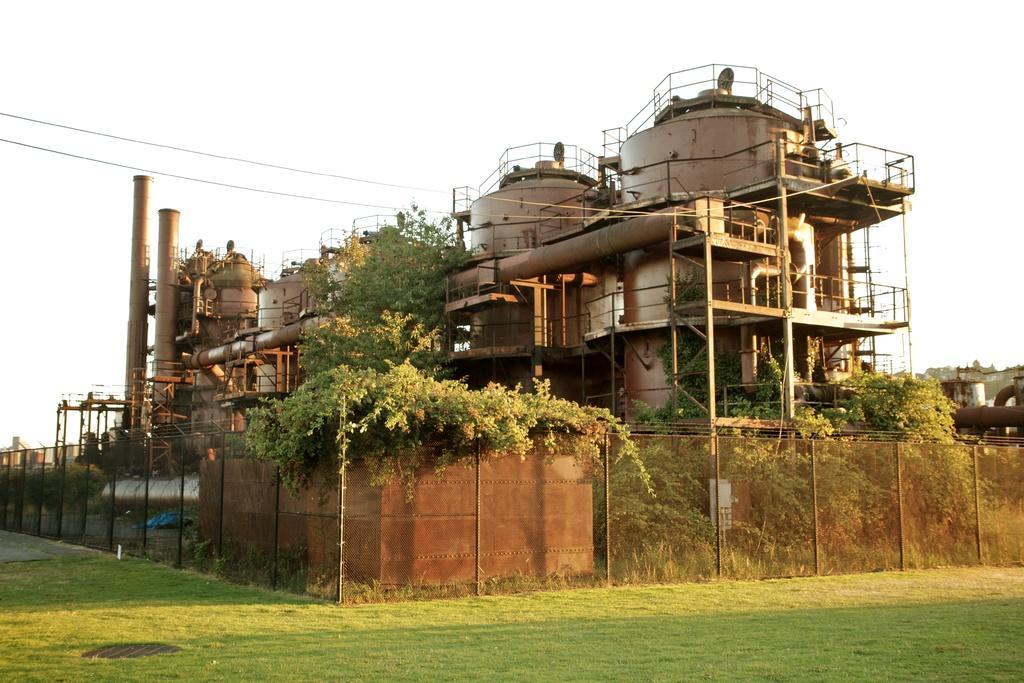Describe this image in one or two sentences. In this image, this looks like a factory. These are the pipes. I think this is a fence. I can see the trees. At the bottom of the image, here is the grass. This is the sky. 